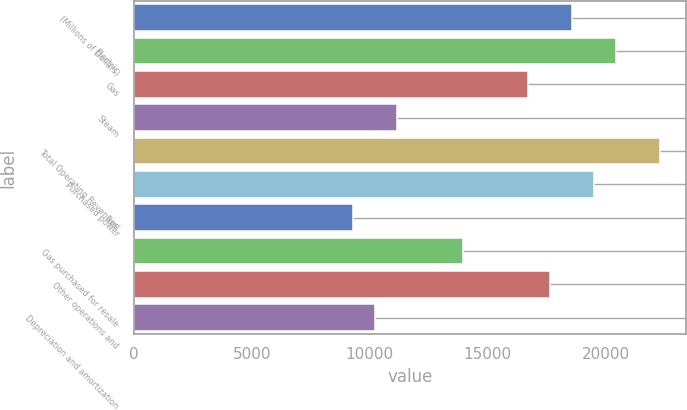<chart> <loc_0><loc_0><loc_500><loc_500><bar_chart><fcel>(Millions of Dollars)<fcel>Electric<fcel>Gas<fcel>Steam<fcel>Total Operating Revenues<fcel>Purchased power<fcel>Fuel<fcel>Gas purchased for resale<fcel>Other operations and<fcel>Depreciation and amortization<nl><fcel>18571<fcel>20427.6<fcel>16714.4<fcel>11144.6<fcel>22284.2<fcel>19499.3<fcel>9288<fcel>13929.5<fcel>17642.7<fcel>10216.3<nl></chart> 